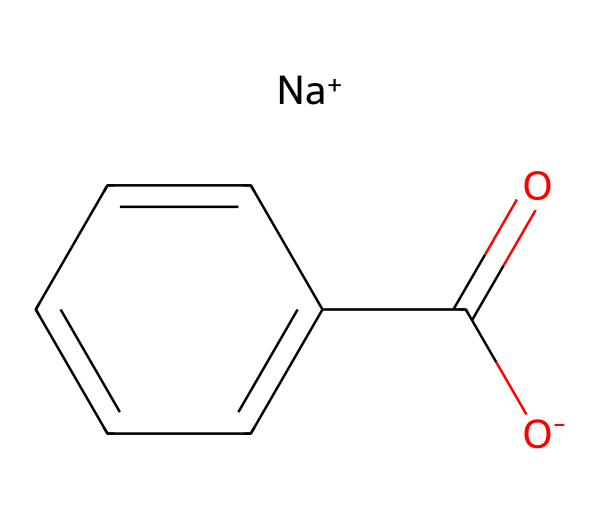What is the molecular formula of sodium benzoate? By analyzing the SMILES representation, we identify the elements present. The compound consists of sodium (Na), carbon (C), oxygen (O), and hydrogen (H). Counting the occurrences leads to the molecular formula C7H5O2Na.
Answer: C7H5O2Na How many carbon atoms are present in sodium benzoate? The SMILES notation includes seven carbon atoms in the phenyl and carboxyl group structure. This can be deduced by counting the "C" symbols in the structure.
Answer: 7 Is sodium benzoate symmetrical? The structure shows that sodium benzoate has a symmetrical phenyl ring, where the five carbon atoms connected to hydrogen atoms present symmetrical arrangements. However, the carboxylate group adds asymmetry due to its position.
Answer: No What type of ion does sodium benzoate form in solution? In solution, sodium benzoate dissociates into sodium ions (Na+) and benzoate ions (C6H5COO-). The presence of the sodium ion indicates it as an ionic compound.
Answer: Ionic How many oxygen atoms are found in sodium benzoate? By examining the SMILES, there are two oxygen atoms in the structure—one in the carboxylate part and one in relation to the sodium ion.
Answer: 2 What functional group signifies sodium benzoate's preservative properties? The carboxylate (COO-) functional group is primarily responsible for sodium benzoate's ability to act as a preservative due to its antimicrobial properties.
Answer: Carboxylate Which chemical class does sodium benzoate belong to? Sodium benzoate is classified under preservatives due to its use in food preservation, specifically as a food additive. The presence of the sodium salt of benzoic acid highlights its classification as a preservative.
Answer: Preservative 